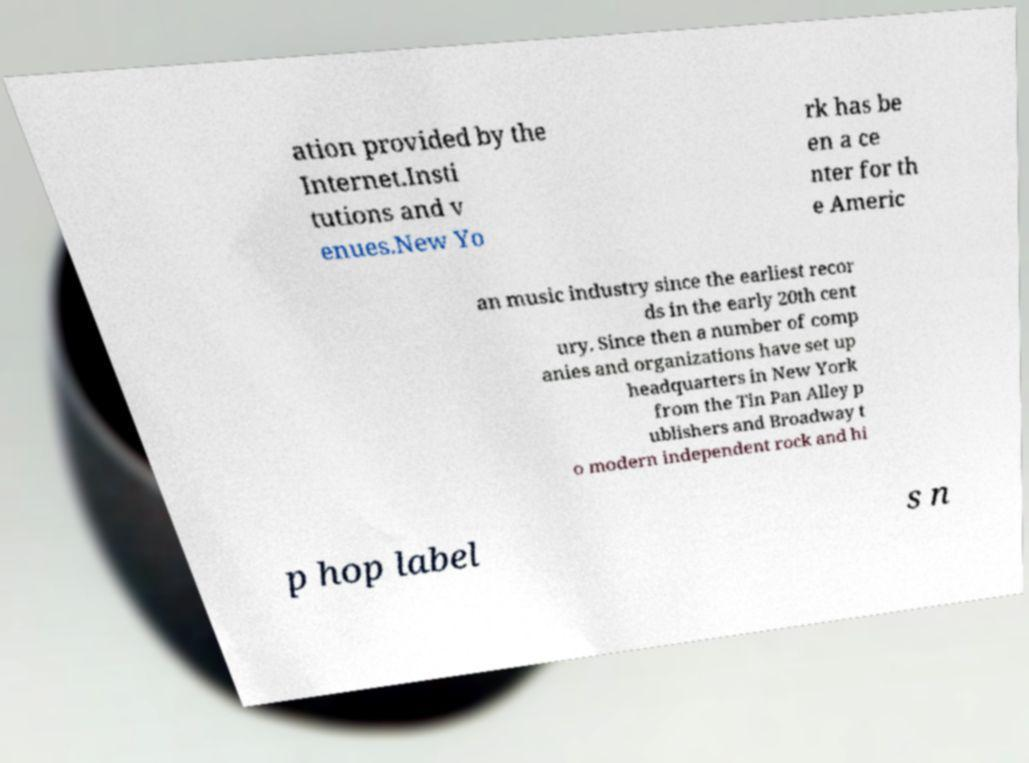What messages or text are displayed in this image? I need them in a readable, typed format. ation provided by the Internet.Insti tutions and v enues.New Yo rk has be en a ce nter for th e Americ an music industry since the earliest recor ds in the early 20th cent ury. Since then a number of comp anies and organizations have set up headquarters in New York from the Tin Pan Alley p ublishers and Broadway t o modern independent rock and hi p hop label s n 